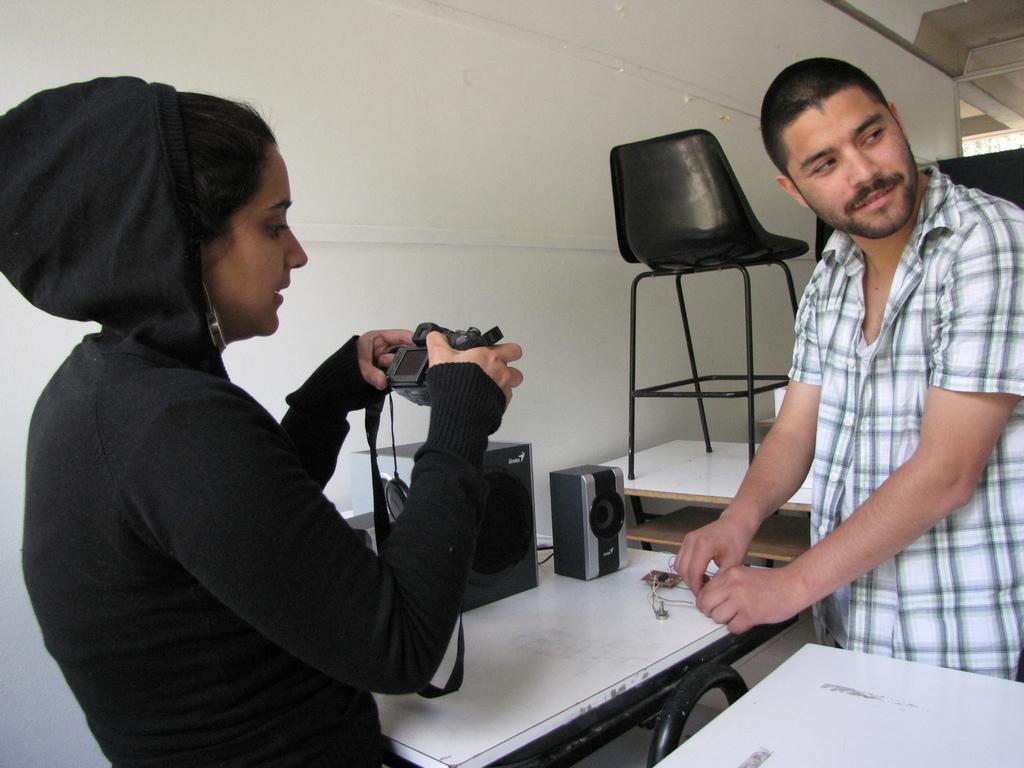Can you describe this image briefly? There are two members in a picture one is a man and the other one is a woman. Woman is holding a camera. In front of them there is a table on which some speakers are placed. Behind them there is a chair. We can observe a wall in the background. 